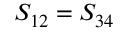Convert formula to latex. <formula><loc_0><loc_0><loc_500><loc_500>S _ { 1 2 } = S _ { 3 4 }</formula> 